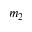Convert formula to latex. <formula><loc_0><loc_0><loc_500><loc_500>m _ { 2 }</formula> 